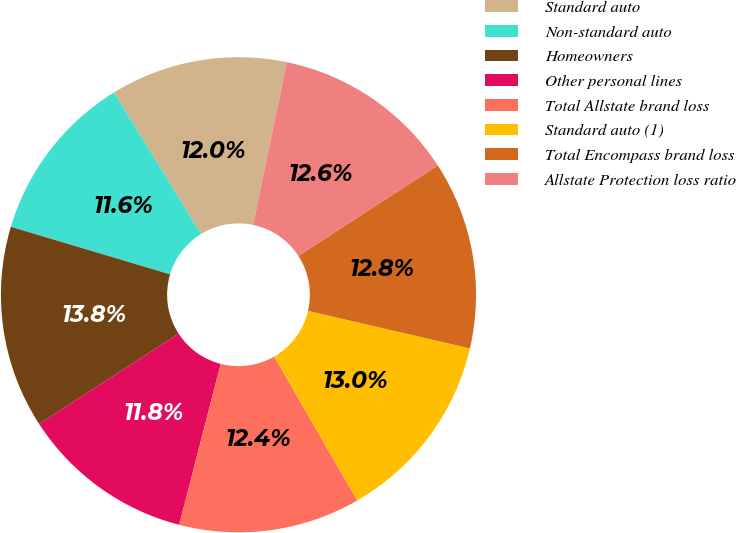<chart> <loc_0><loc_0><loc_500><loc_500><pie_chart><fcel>Standard auto<fcel>Non-standard auto<fcel>Homeowners<fcel>Other personal lines<fcel>Total Allstate brand loss<fcel>Standard auto (1)<fcel>Total Encompass brand loss<fcel>Allstate Protection loss ratio<nl><fcel>12.04%<fcel>11.61%<fcel>13.77%<fcel>11.83%<fcel>12.35%<fcel>13.04%<fcel>12.79%<fcel>12.57%<nl></chart> 